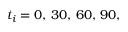<formula> <loc_0><loc_0><loc_500><loc_500>t _ { i } = 0 , \, 3 0 , \, 6 0 , \, 9 0 ,</formula> 